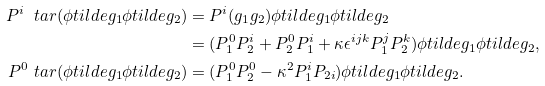Convert formula to latex. <formula><loc_0><loc_0><loc_500><loc_500>P ^ { i } \ t a r ( \phi t i l d e { g _ { 1 } } \phi t i l d e { g _ { 2 } } ) & = P ^ { i } ( g _ { 1 } g _ { 2 } ) \phi t i l d e { g _ { 1 } } \phi t i l d e { g _ { 2 } } \\ & = ( P _ { 1 } ^ { 0 } P _ { 2 } ^ { i } + P ^ { 0 } _ { 2 } P _ { 1 } ^ { i } + \kappa \epsilon ^ { i j k } P _ { 1 } ^ { j } P _ { 2 } ^ { k } ) \phi t i l d e { g _ { 1 } } \phi t i l d e { g _ { 2 } } , \\ P ^ { 0 } \ t a r ( \phi t i l d e { g _ { 1 } } \phi t i l d e { g _ { 2 } } ) & = ( P _ { 1 } ^ { 0 } P _ { 2 } ^ { 0 } - \kappa ^ { 2 } P _ { 1 } ^ { i } P _ { 2 i } ) \phi t i l d e { g _ { 1 } } \phi t i l d e { g _ { 2 } } .</formula> 